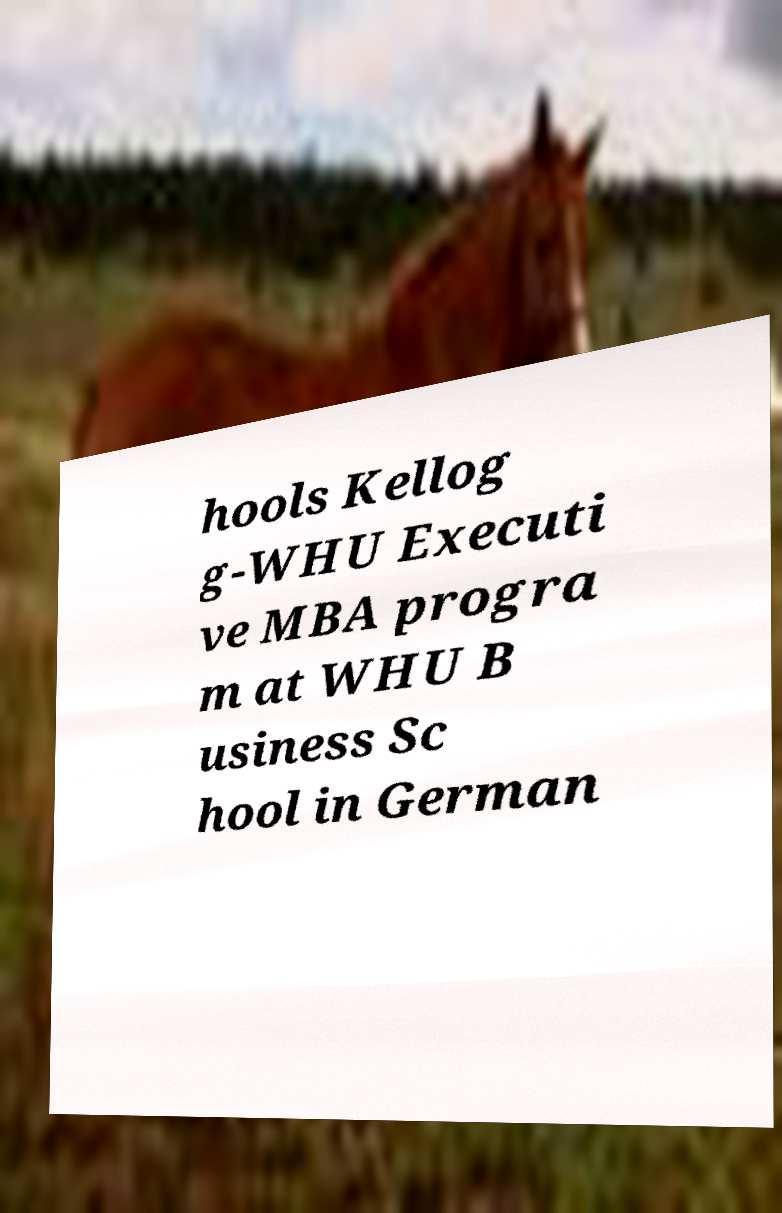For documentation purposes, I need the text within this image transcribed. Could you provide that? hools Kellog g-WHU Executi ve MBA progra m at WHU B usiness Sc hool in German 